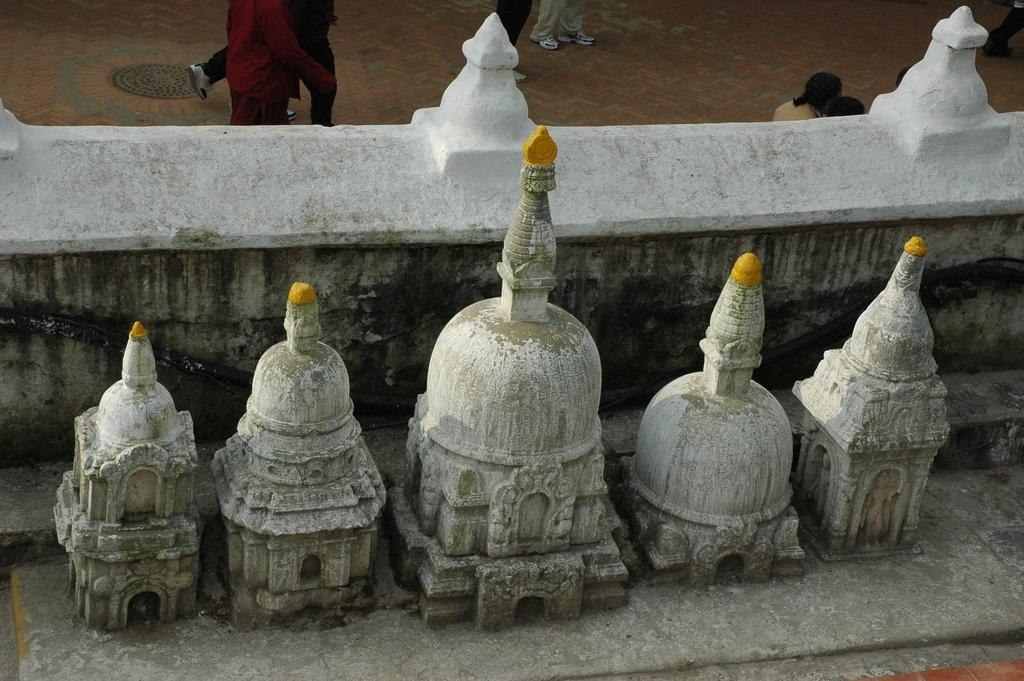What type of artwork is depicted in the image? There are stone carvings in the image. What structure is present in the image? There is a wall in the image. Can you describe the people visible in the background of the image? Unfortunately, the facts provided do not give any details about the people in the background. How does the stone carving increase the sense of attention in the image? The stone carving does not increase the sense of attention in the image, as the concept of "attention" is not mentioned in the provided facts. 